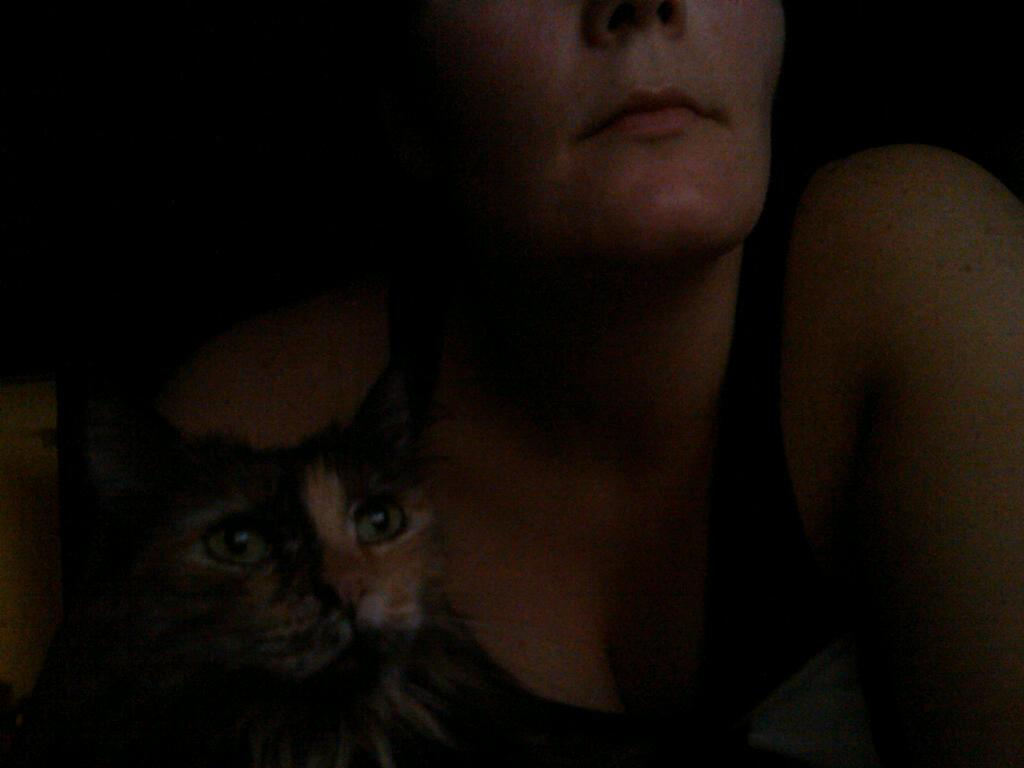Who is present in the image? There is a woman in the image. What type of animal is also present in the image? There is a cat in the image. Can you see a giraffe in the image? No, there is no giraffe present in the image. What type of structure is visible in the image? There is no specific structure mentioned in the provided facts, so it cannot be determined from the image. 